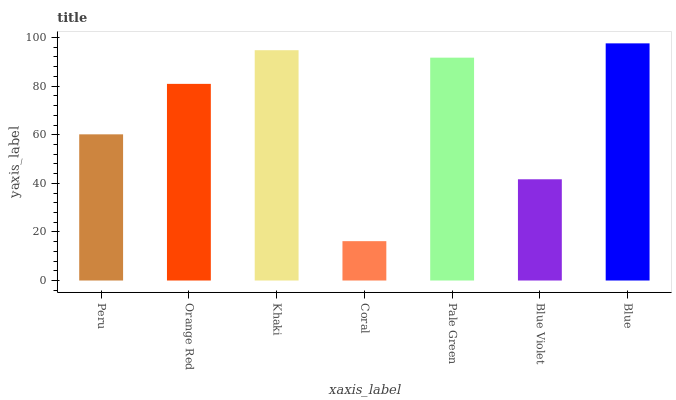Is Coral the minimum?
Answer yes or no. Yes. Is Blue the maximum?
Answer yes or no. Yes. Is Orange Red the minimum?
Answer yes or no. No. Is Orange Red the maximum?
Answer yes or no. No. Is Orange Red greater than Peru?
Answer yes or no. Yes. Is Peru less than Orange Red?
Answer yes or no. Yes. Is Peru greater than Orange Red?
Answer yes or no. No. Is Orange Red less than Peru?
Answer yes or no. No. Is Orange Red the high median?
Answer yes or no. Yes. Is Orange Red the low median?
Answer yes or no. Yes. Is Blue the high median?
Answer yes or no. No. Is Blue Violet the low median?
Answer yes or no. No. 